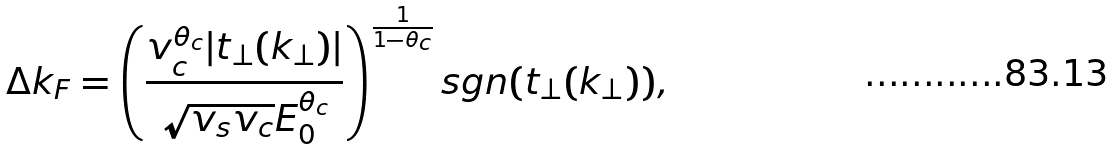<formula> <loc_0><loc_0><loc_500><loc_500>\Delta k _ { F } = \left ( \frac { v _ { c } ^ { \theta _ { c } } | t _ { \perp } ( k _ { \perp } ) | } { \sqrt { v _ { s } v _ { c } } E _ { 0 } ^ { \theta _ { c } } } \right ) ^ { \frac { 1 } { 1 - \theta _ { c } } } s g n ( t _ { \perp } ( k _ { \perp } ) ) ,</formula> 